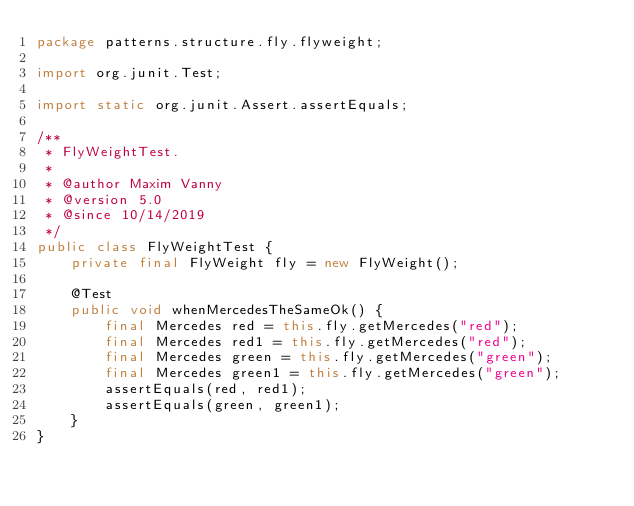Convert code to text. <code><loc_0><loc_0><loc_500><loc_500><_Java_>package patterns.structure.fly.flyweight;

import org.junit.Test;

import static org.junit.Assert.assertEquals;

/**
 * FlyWeightTest.
 *
 * @author Maxim Vanny
 * @version 5.0
 * @since 10/14/2019
 */
public class FlyWeightTest {
    private final FlyWeight fly = new FlyWeight();

    @Test
    public void whenMercedesTheSameOk() {
        final Mercedes red = this.fly.getMercedes("red");
        final Mercedes red1 = this.fly.getMercedes("red");
        final Mercedes green = this.fly.getMercedes("green");
        final Mercedes green1 = this.fly.getMercedes("green");
        assertEquals(red, red1);
        assertEquals(green, green1);
    }
}
</code> 